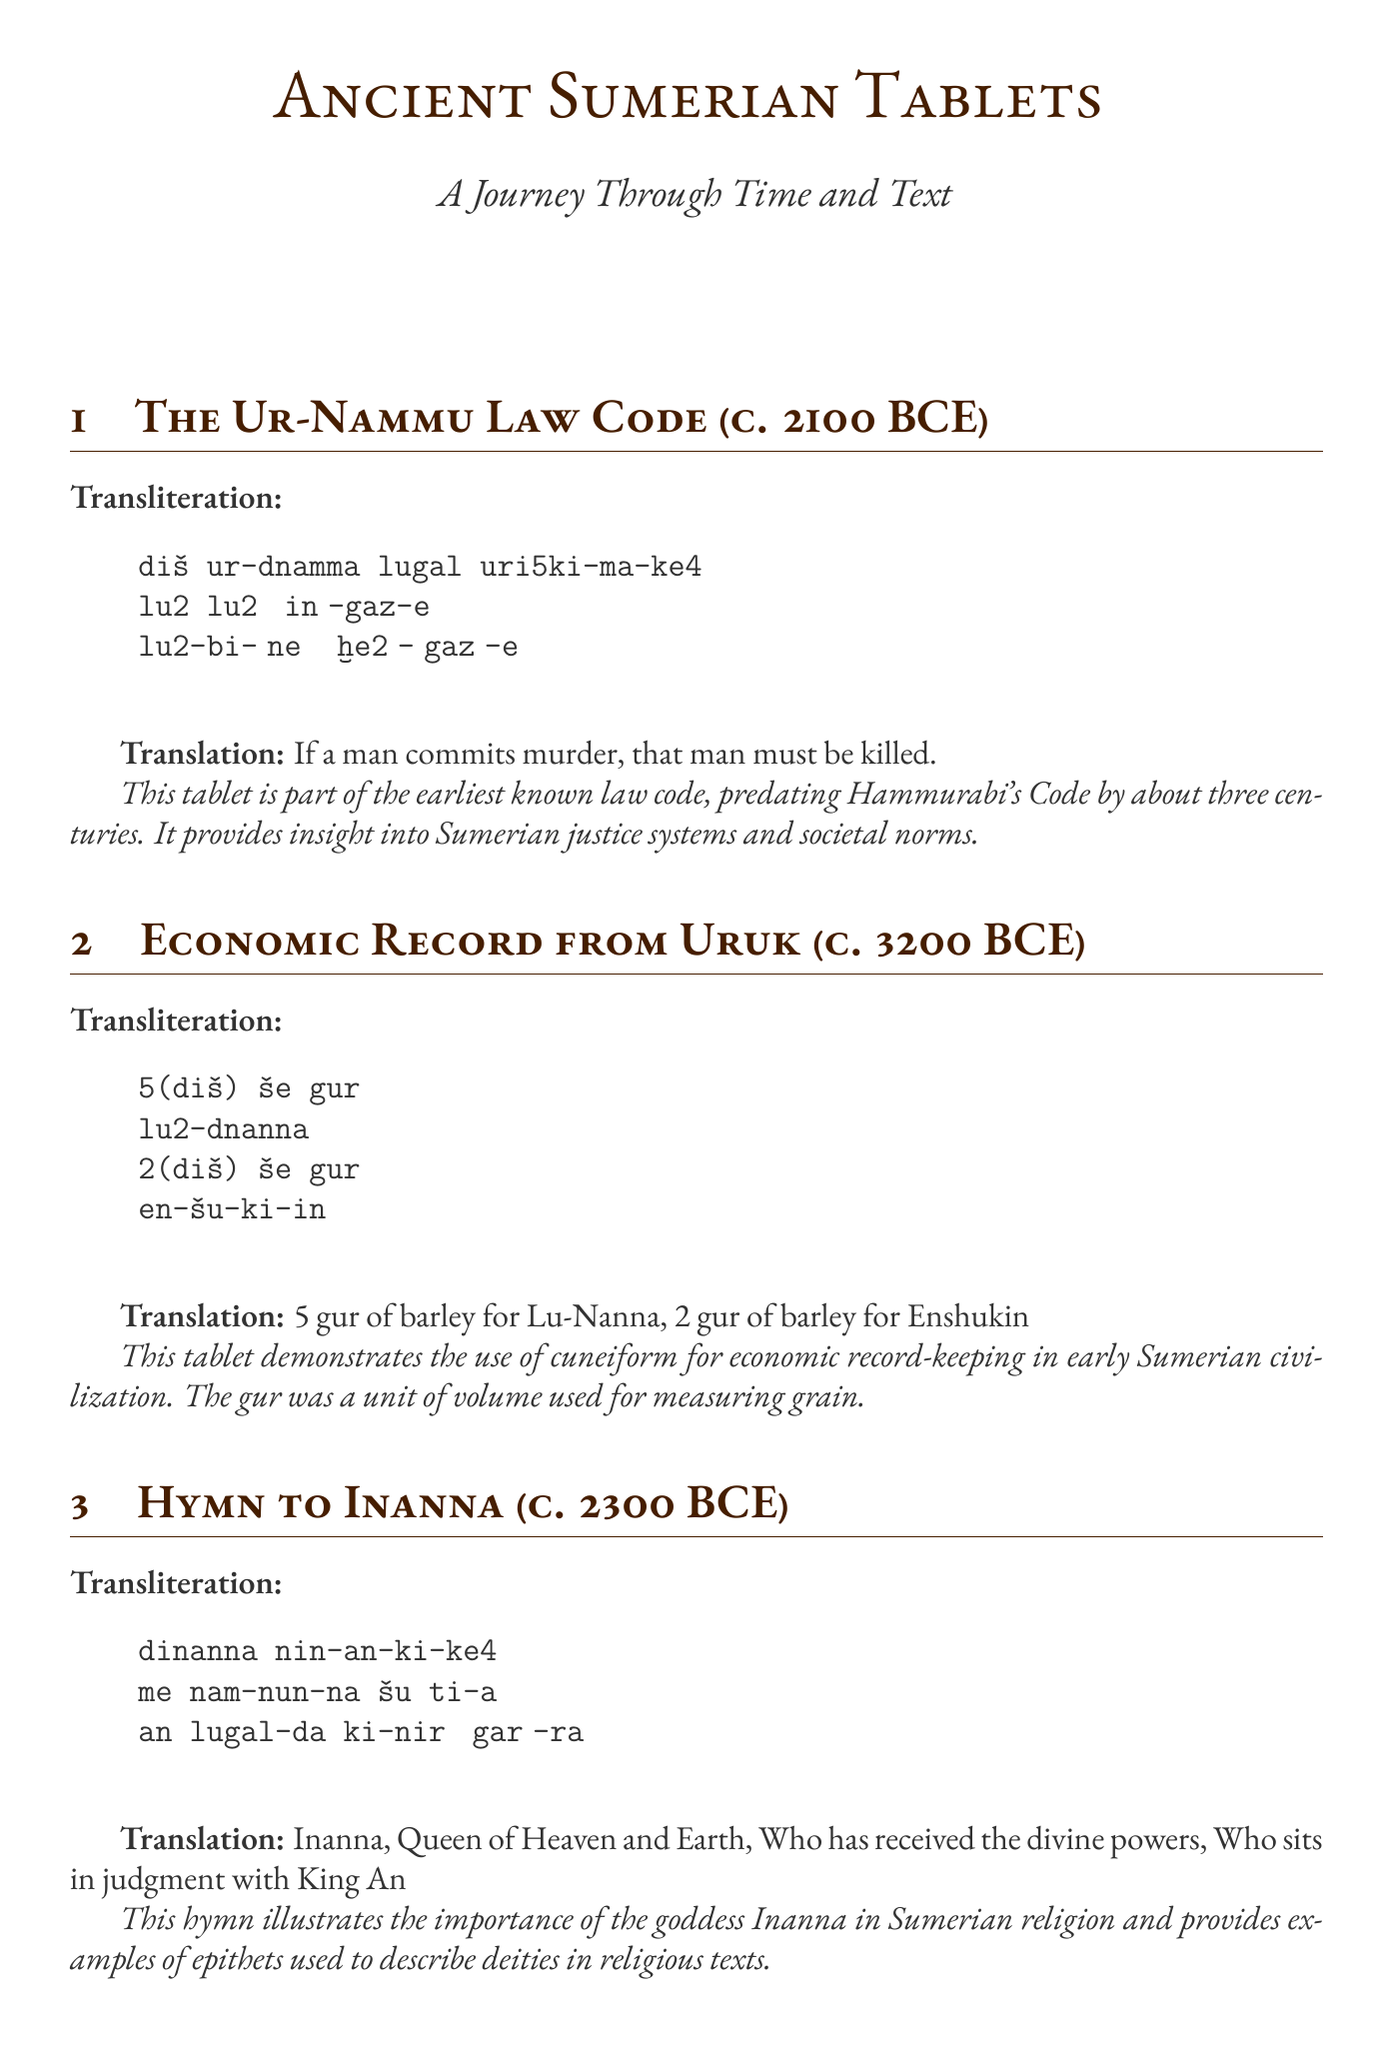What is the title of the first tablet? The first tablet is titled "Sumerian Cuneiform Tablet: The Ur-Nammu Law Code".
Answer: Sumerian Cuneiform Tablet: The Ur-Nammu Law Code What is the date of the Economic Record from Uruk? The Economic Record from Uruk is dated to circa 3200 BCE.
Answer: circa 3200 BCE How many gur of barley was allocated to Lu-Nanna? The document states that 5 gur of barley was allocated to Lu-Nanna.
Answer: 5 gur Who is the goddess praised in "Hymn to Inanna"? The hymn praises the goddess Inanna.
Answer: Inanna What does the transliteration of the Curse of Agade describe? The transliteration describes the destruction of a city and its sanctuary becoming silent.
Answer: destruction of a city What numerical system does the Mathematical Tablet from Uruk exemplify? The tablet exemplifies the Sumerian sexagesimal (base-60) number system.
Answer: sexagesimal (base-60) What type of text is "The Curse of Agade"? "The Curse of Agade" is a literary text.
Answer: literary text Which tablet is part of the earliest known law code? The Ur-Nammu Law Code tablet is part of the earliest known law code.
Answer: Ur-Nammu Law Code What do the contextual notes for the Hymn to Inanna highlight? The contextual notes highlight the importance of the goddess Inanna in Sumerian religion.
Answer: importance of the goddess Inanna 